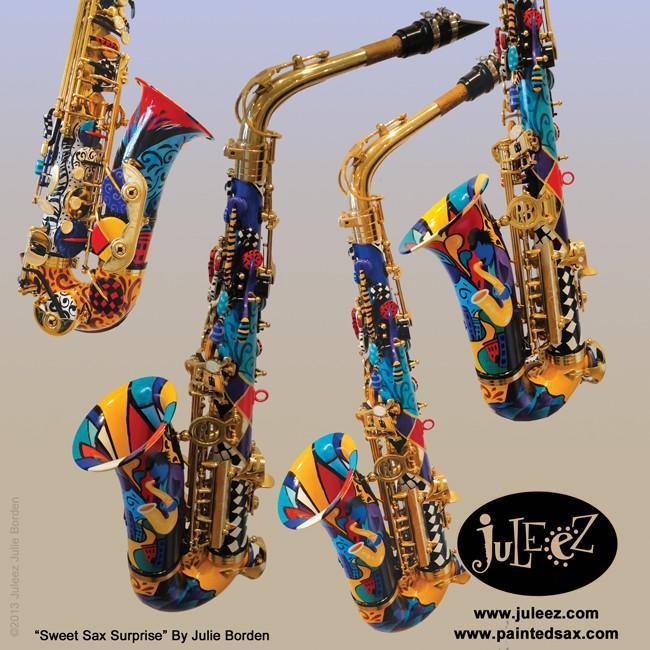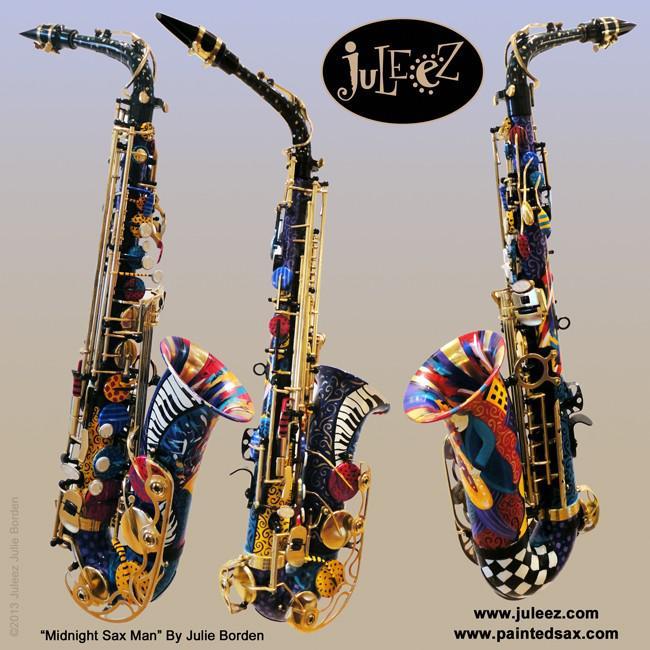The first image is the image on the left, the second image is the image on the right. For the images shown, is this caption "An image shows just one view of one bright blue saxophone with brass-colored buttons." true? Answer yes or no. No. The first image is the image on the left, the second image is the image on the right. Assess this claim about the two images: "There are more instruments shown in the image on the left.". Correct or not? Answer yes or no. Yes. 